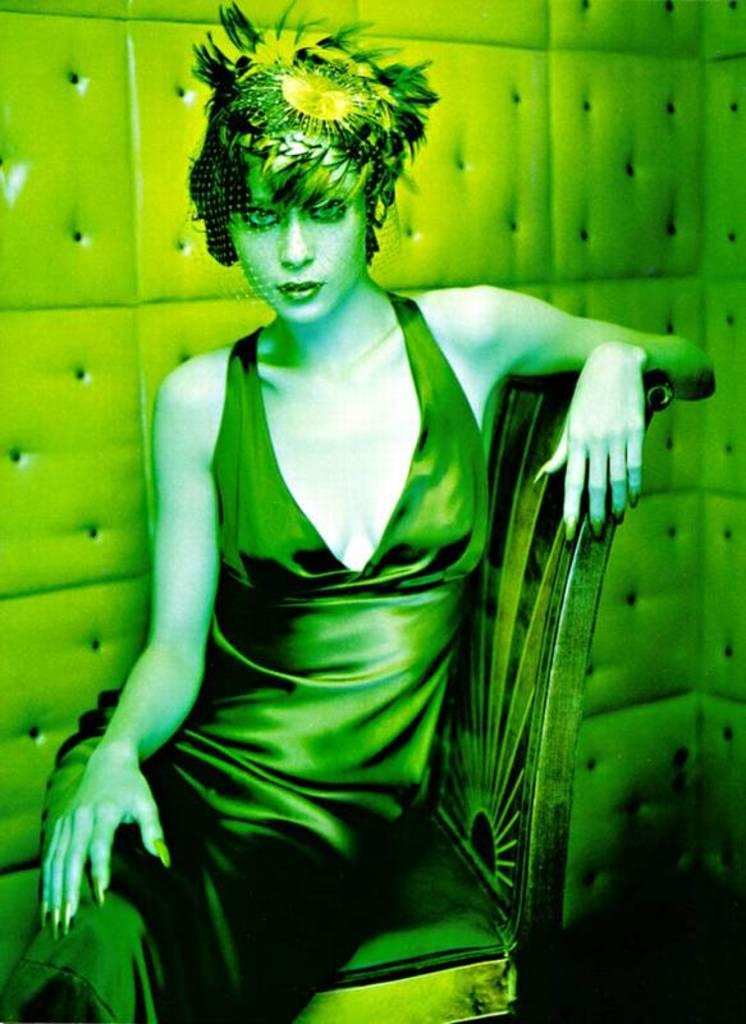What is the dominant color in the image? The image has a predominantly green color. Can you describe the person in the image? There is a woman in the image. What is the woman doing in the image? The woman is sitting on a chair. What type of organization is the woman representing in the image? There is no indication in the image that the woman is representing any organization. 